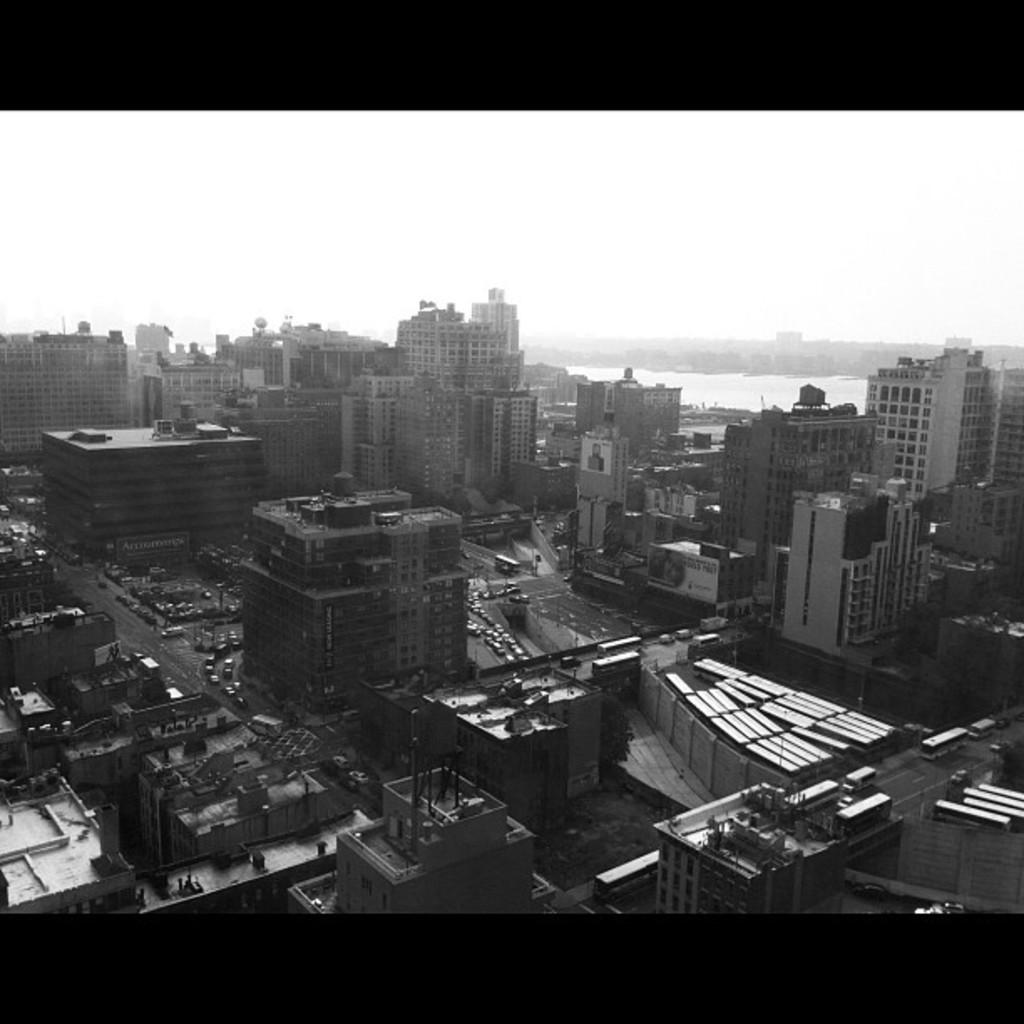What type of structures can be seen in the image? There are buildings in the image. What type of transportation is visible in the image? There are cars, buses, and other vehicles in the image. What is visible at the top of the image? The sky is visible at the top of the image. What is the color scheme of the image? The image is black and white. Can you tell me where the manager's brain is located in the image? There is no manager or brain present in the image. What type of curve can be seen in the image? There is no curve visible in the image; it features buildings, vehicles, and a black and white color scheme. 